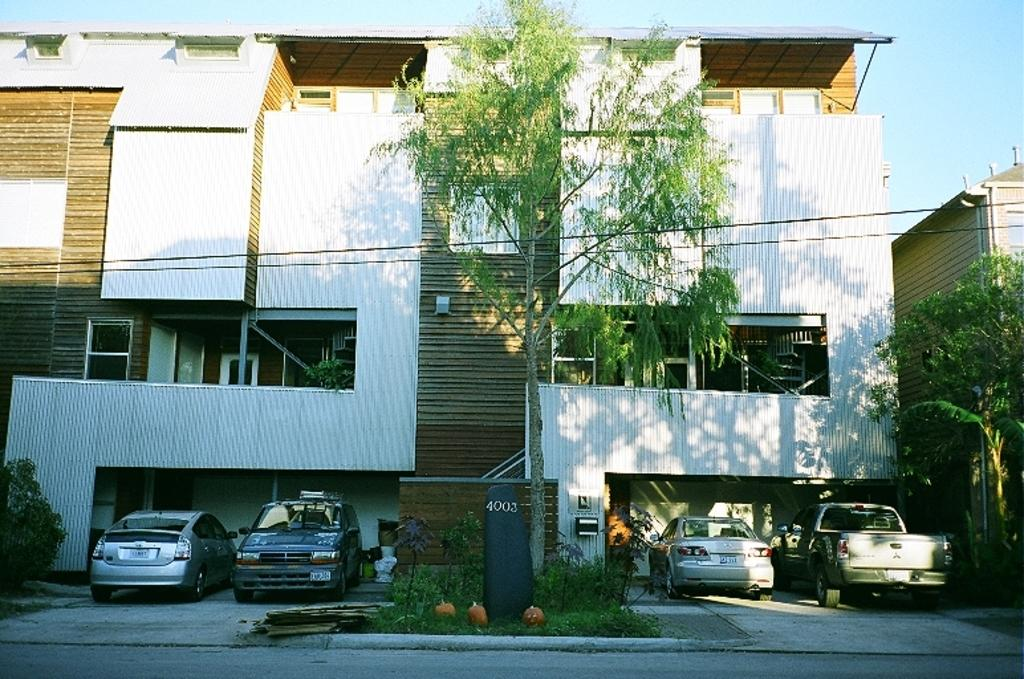What type of structure is present in the image? There is a building in the image. How many cars are parked near the building? There are four cars on either side of the building, making a total of eight cars. What type of vegetation can be seen in the image? There are trees and plants in the image. What part of the natural environment is visible in the image? The sky is visible in the top right corner of the image. What type of hydrant is present in the image? There is no hydrant present in the image. What type of meeting is taking place in the image? There is no meeting depicted in the image. 